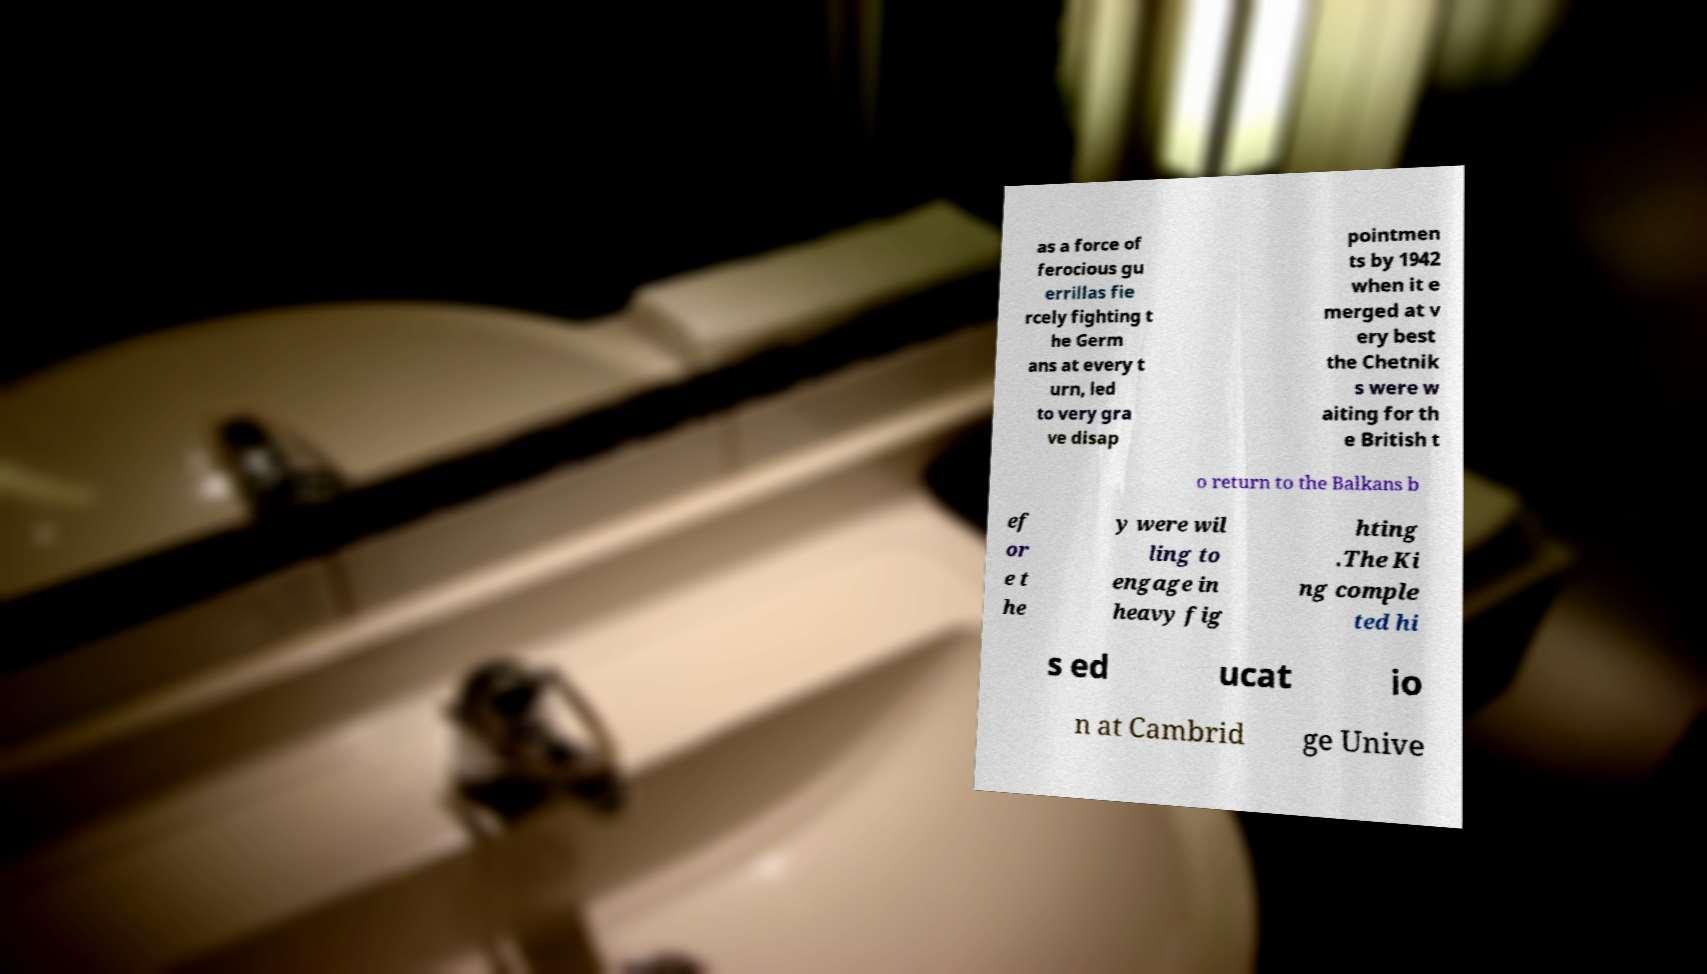I need the written content from this picture converted into text. Can you do that? as a force of ferocious gu errillas fie rcely fighting t he Germ ans at every t urn, led to very gra ve disap pointmen ts by 1942 when it e merged at v ery best the Chetnik s were w aiting for th e British t o return to the Balkans b ef or e t he y were wil ling to engage in heavy fig hting .The Ki ng comple ted hi s ed ucat io n at Cambrid ge Unive 